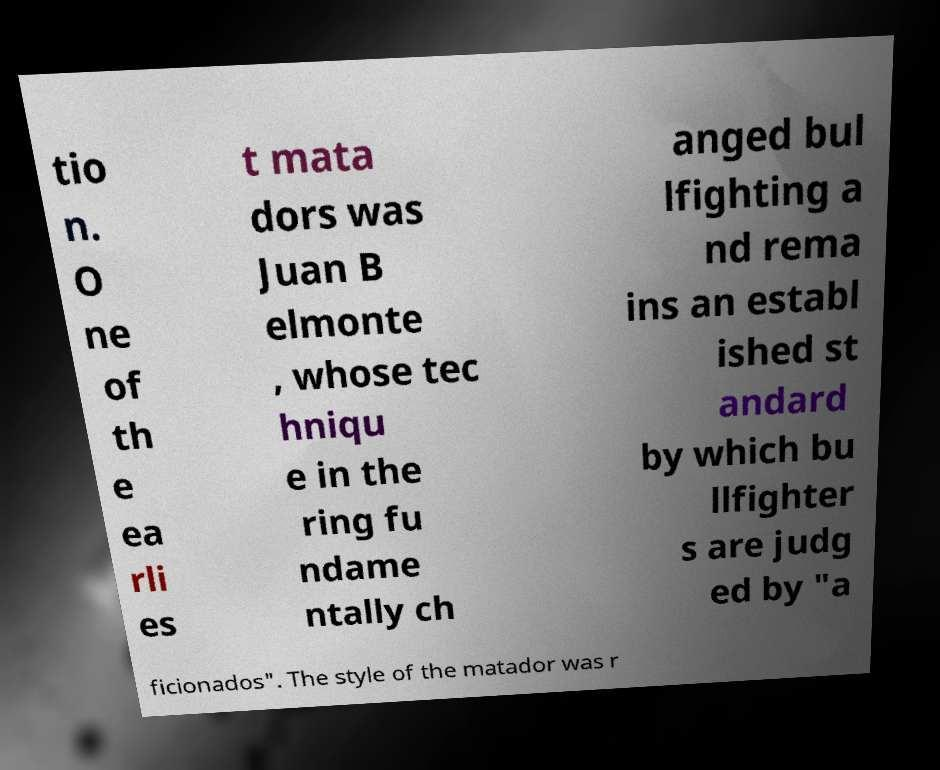Please read and relay the text visible in this image. What does it say? tio n. O ne of th e ea rli es t mata dors was Juan B elmonte , whose tec hniqu e in the ring fu ndame ntally ch anged bul lfighting a nd rema ins an establ ished st andard by which bu llfighter s are judg ed by "a ficionados". The style of the matador was r 